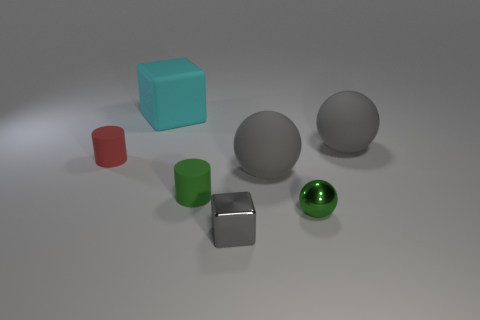Add 3 tiny red rubber objects. How many objects exist? 10 Subtract all cylinders. How many objects are left? 5 Add 2 tiny purple rubber spheres. How many tiny purple rubber spheres exist? 2 Subtract 2 gray spheres. How many objects are left? 5 Subtract all tiny green spheres. Subtract all red matte things. How many objects are left? 5 Add 5 green cylinders. How many green cylinders are left? 6 